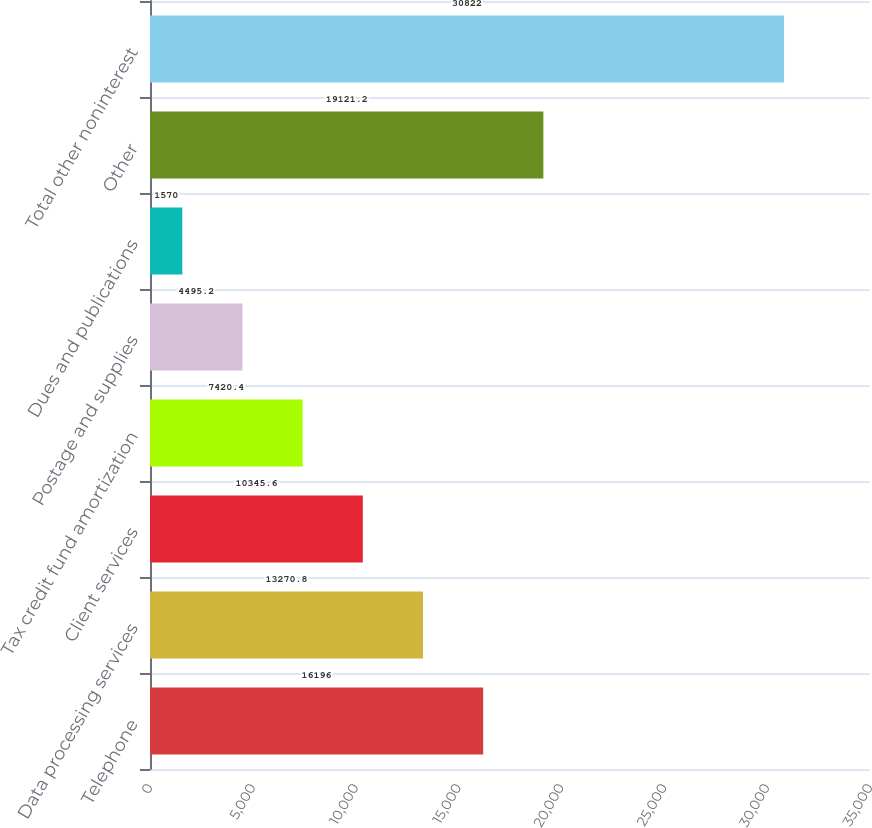Convert chart to OTSL. <chart><loc_0><loc_0><loc_500><loc_500><bar_chart><fcel>Telephone<fcel>Data processing services<fcel>Client services<fcel>Tax credit fund amortization<fcel>Postage and supplies<fcel>Dues and publications<fcel>Other<fcel>Total other noninterest<nl><fcel>16196<fcel>13270.8<fcel>10345.6<fcel>7420.4<fcel>4495.2<fcel>1570<fcel>19121.2<fcel>30822<nl></chart> 